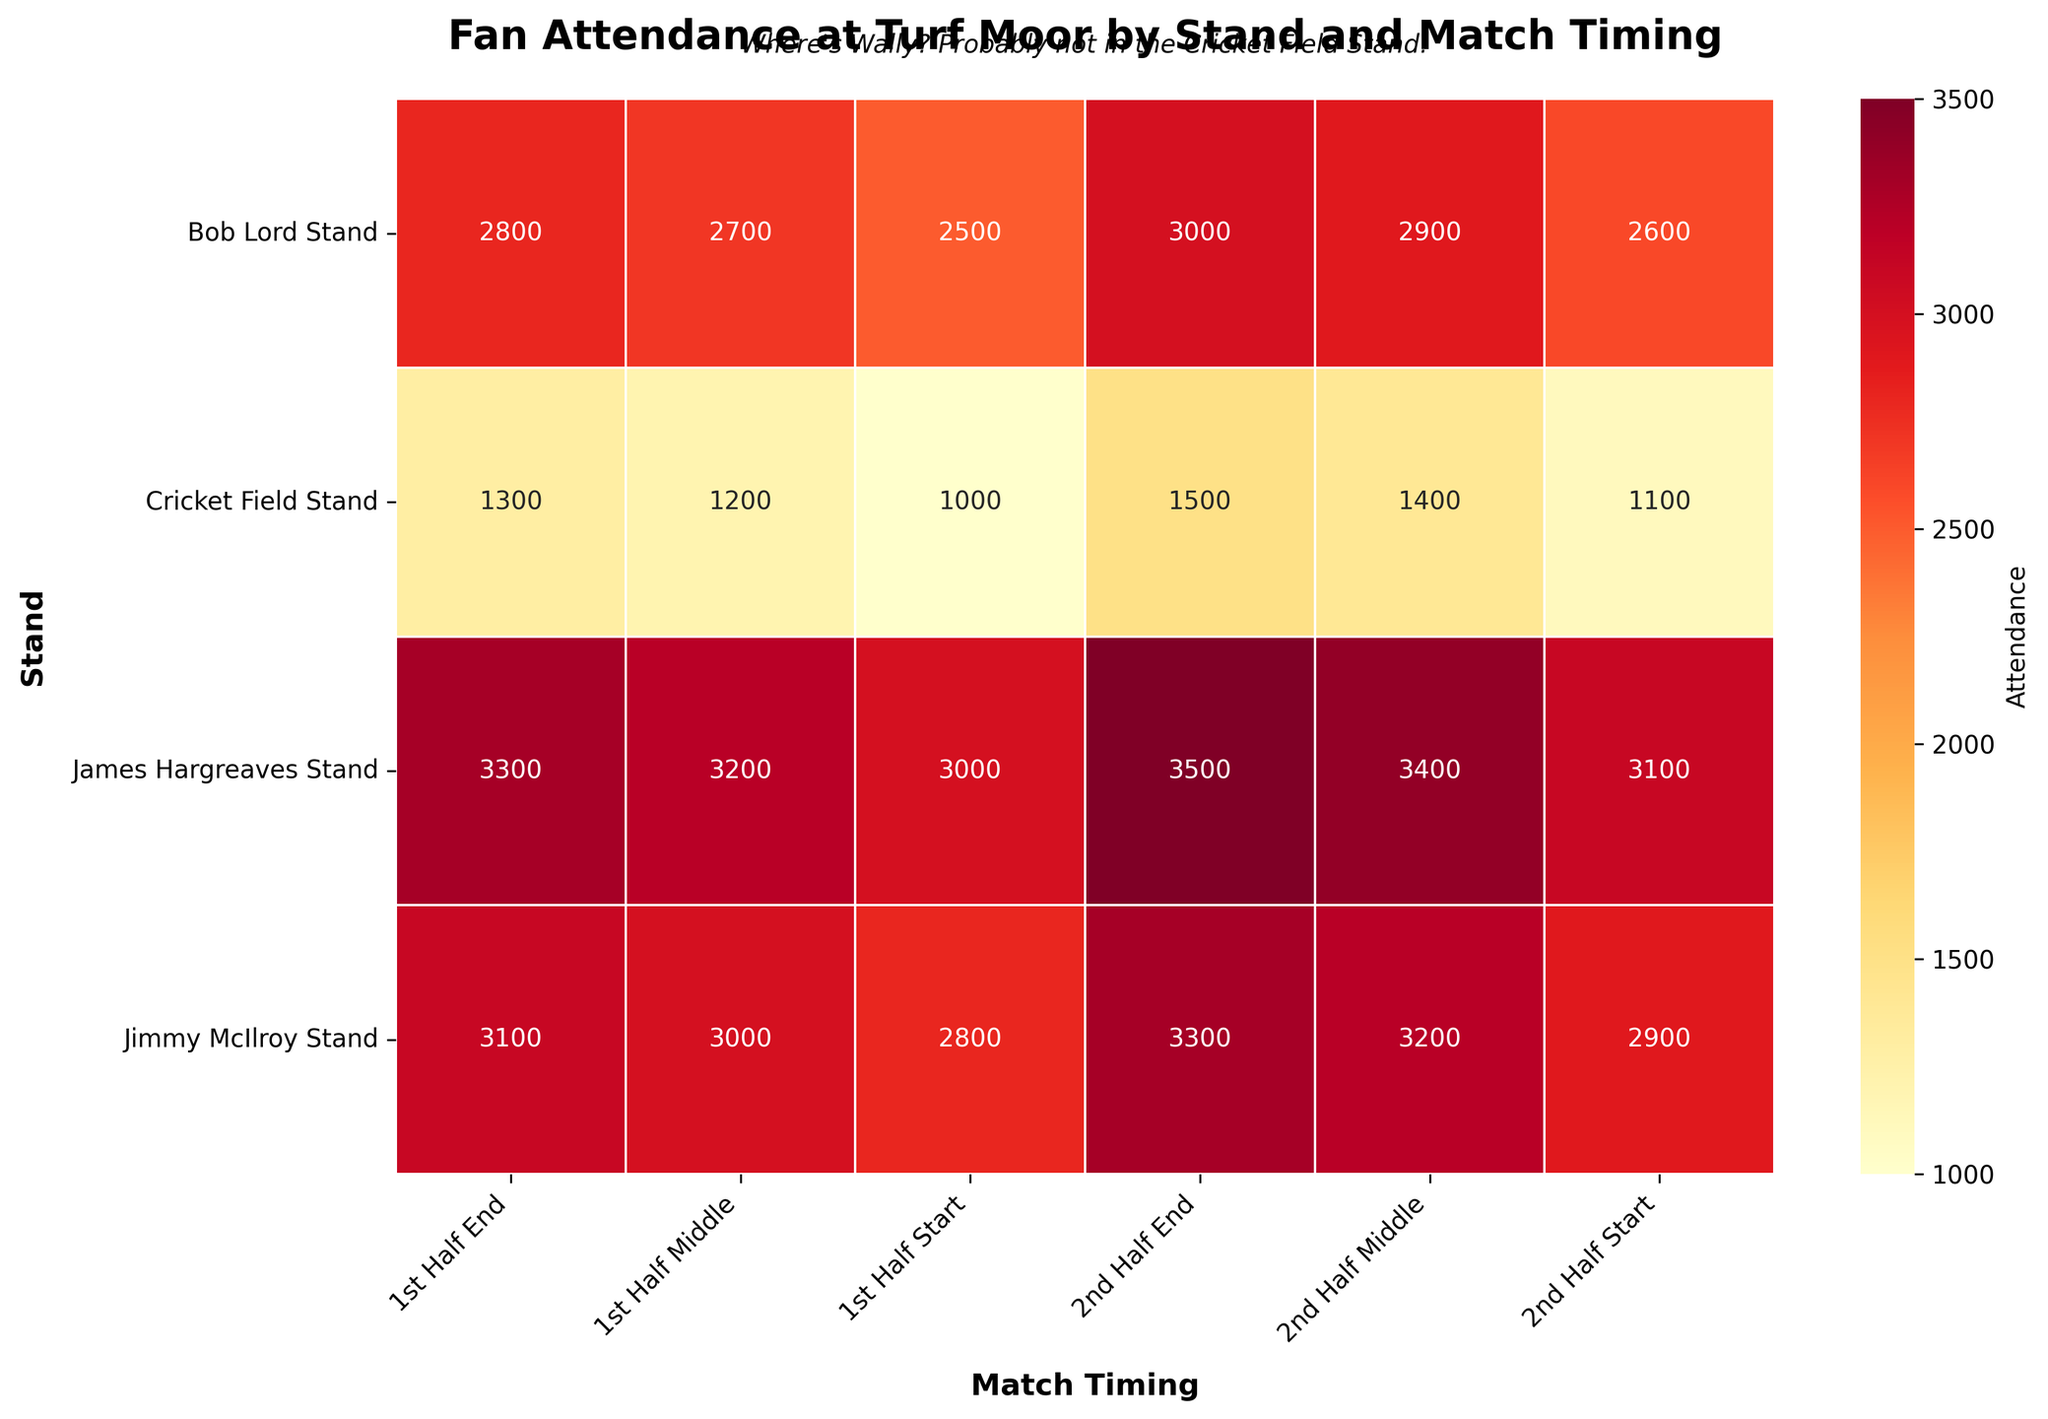What's the total attendance in the James Hargreaves Stand during the 2nd half? Add the attendance figures for the 2nd Half Start, 2nd Half Middle, and 2nd Half End in the James Hargreaves Stand: 3100 + 3400 + 3500 = 10000
Answer: 10000 Which Stand has the lowest attendance during the 1st Half Start? Compare the attendance figures for the 1st Half Start across all stands. The Cricket Field Stand has the lowest with 1000
Answer: Cricket Field Stand What is the attendance difference between the start and end of the match in the Bob Lord Stand? Subtract the 1st Half Start attendance from the 2nd Half End attendance in the Bob Lord Stand: 3000 - 2500 = 500
Answer: 500 Which Stand has the highest average attendance throughout the match? Calculate the average attendance for each stand by summing their attendance over all periods and then dividing by the number of periods; the James Hargreaves Stand has the highest average: (3000 + 3200 + 3300 + 3100 + 3400 + 3500) / 6 = 3250
Answer: James Hargreaves Stand What's the trend in attendance from the start to the end of the match in the Cricket Field Stand? The attendance in the Cricket Field Stand increases from the 1st Half Start (1000) to 1st Half Middle (1200), then to 1st Half End (1300), and continues increasing through the 2nd Half Start (1100), 2nd Half Middle (1400), and 2nd Half End (1500)
Answer: Increasing Which stand had more attendees in the middle of the second half, Bob Lord Stand or Jimmy McIlroy Stand? Compare the attendance figures in the 2nd Half Middle for Bob Lord Stand (2900) and Jimmy McIlroy Stand (3200). The Jimmy McIlroy Stand has more attendees
Answer: Jimmy McIlroy Stand How much does the attendance increase from the 1st Half Start to the 1st Half End in the James Hargreaves Stand? Subtract the 1st Half Start attendance from the 1st Half End attendance in the James Hargreaves Stand: 3300 - 3000 = 300
Answer: 300 Which match timing has the highest overall attendance in the Jimmy McIlroy Stand? Compare the attendance figures for each match timing in the Jimmy McIlroy Stand: 1st Half End (3100), 2nd Half Middle (3200), and 2nd Half End (3300). The 2nd Half End has the highest
Answer: 2nd Half End What's the combined attendance of all stands at the 2nd Half End? Sum the attendance at the 2nd Half End for all stands: 3500 (JH) + 3000 (BL) + 3300 (JM) + 1500 (CF) = 11300
Answer: 11300 